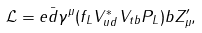<formula> <loc_0><loc_0><loc_500><loc_500>\mathcal { L } = e \bar { d } \gamma ^ { \mu } ( f _ { L } V _ { u d } ^ { * } V _ { t b } P _ { L } ) b Z _ { \mu } ^ { \prime } ,</formula> 